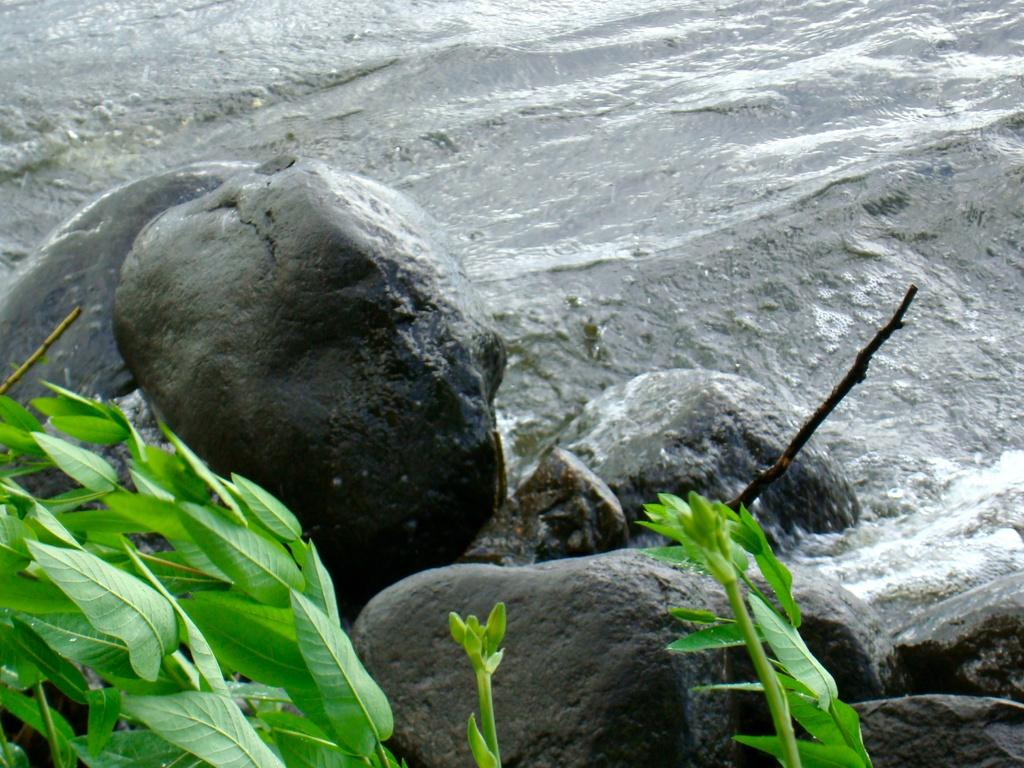What is one of the main elements visible in the image? Water is visible in the image. What type of objects can be seen in the water? There are stones in the image. What other natural elements are present in the image? Leaves and buds are visible in the image. What part of a tree can be seen in the image? There is a branch of a tree in the image. How many beggars can be seen in the image? There are no beggars present in the image. Is it raining in the image? The provided facts do not mention rain, and there is no indication of rain in the image. 